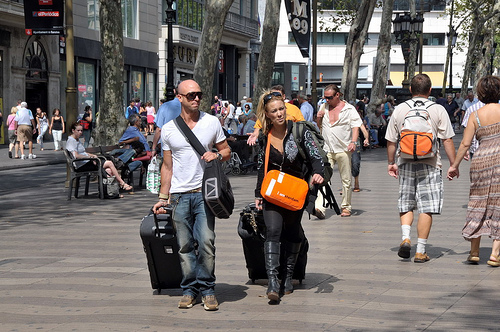Please extract the text content from this image. 09 M 